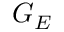Convert formula to latex. <formula><loc_0><loc_0><loc_500><loc_500>G _ { E }</formula> 